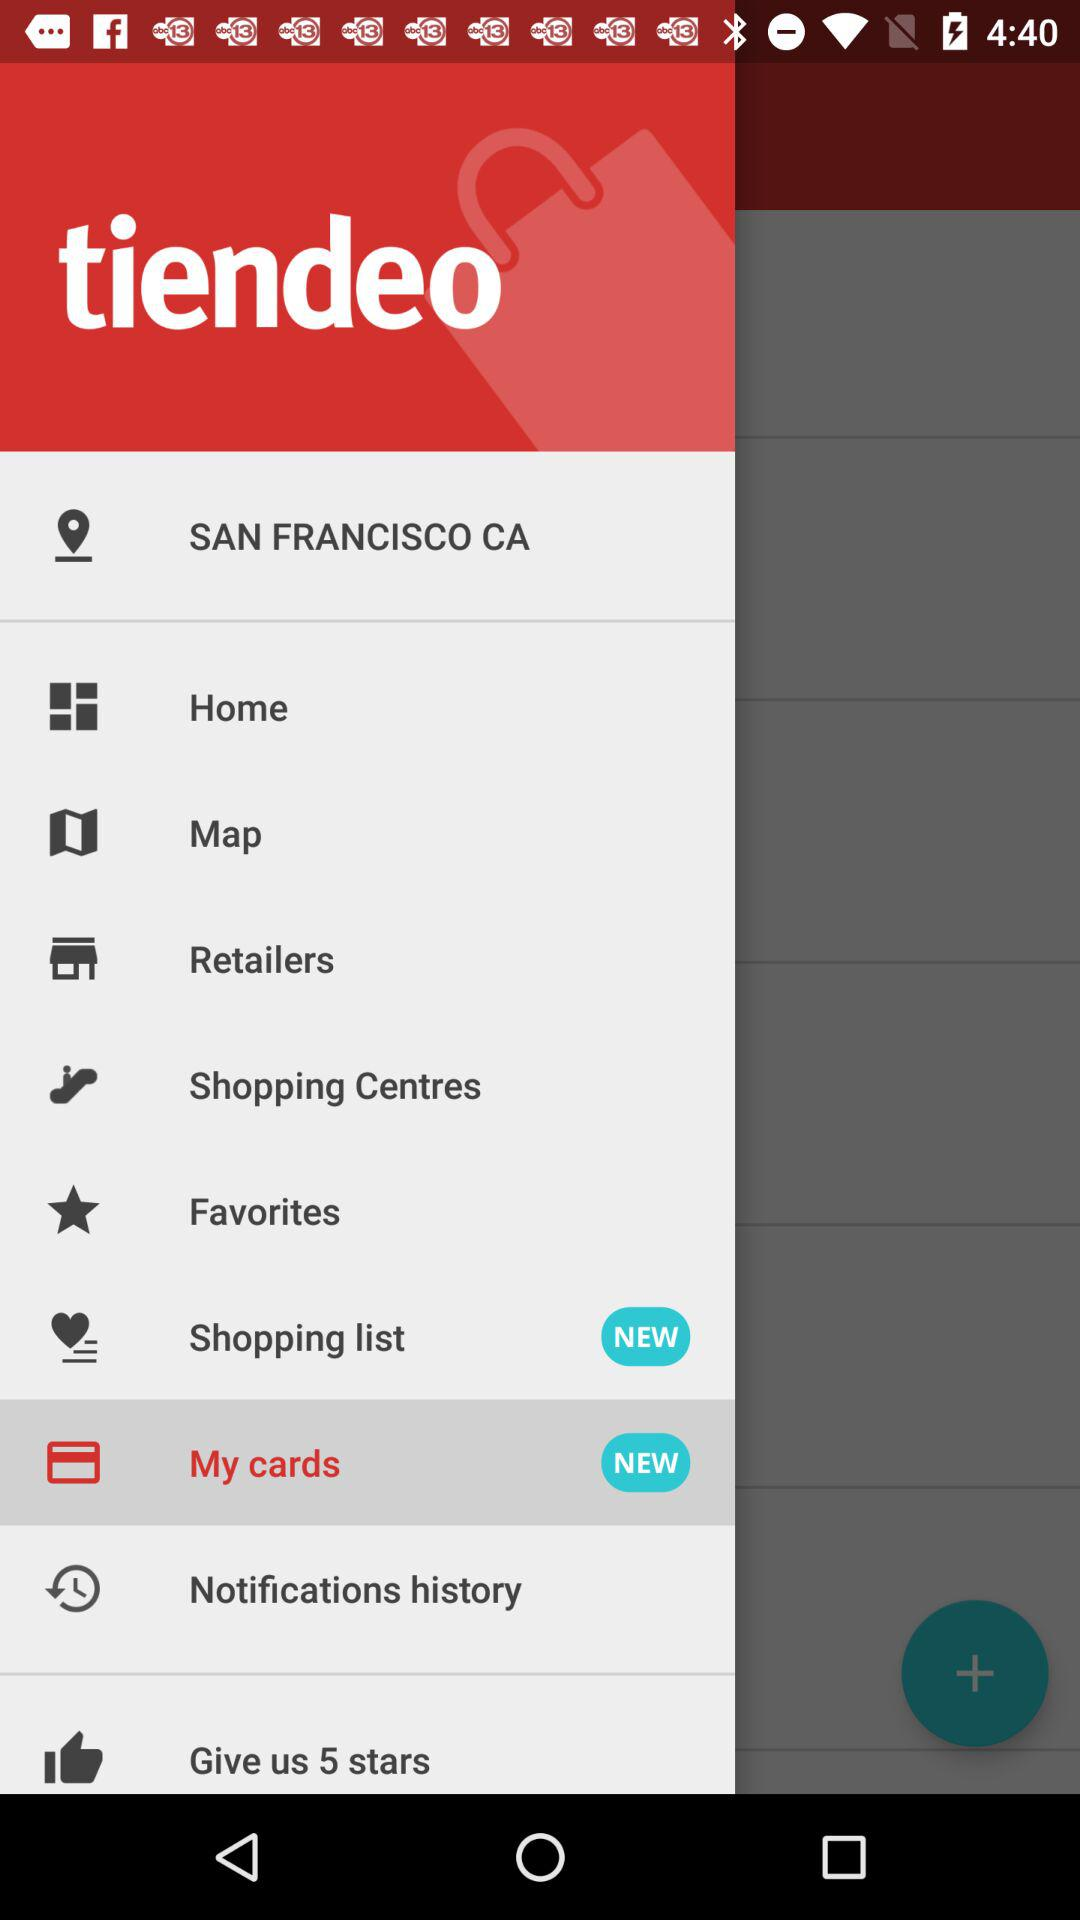What is the given location? The given location is San Francisco CA. 